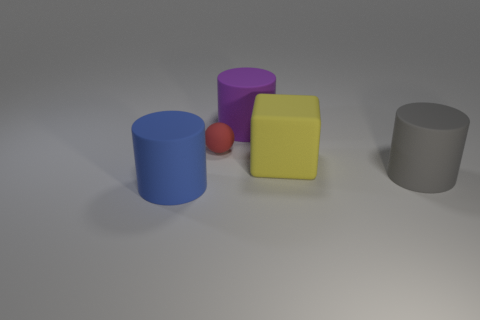Could these objects be part of a child's toy set? It's possible the objects are part of a toy set due to their bright colors and simple geometric shapes, which are characteristics often associated with children's educational toys. 